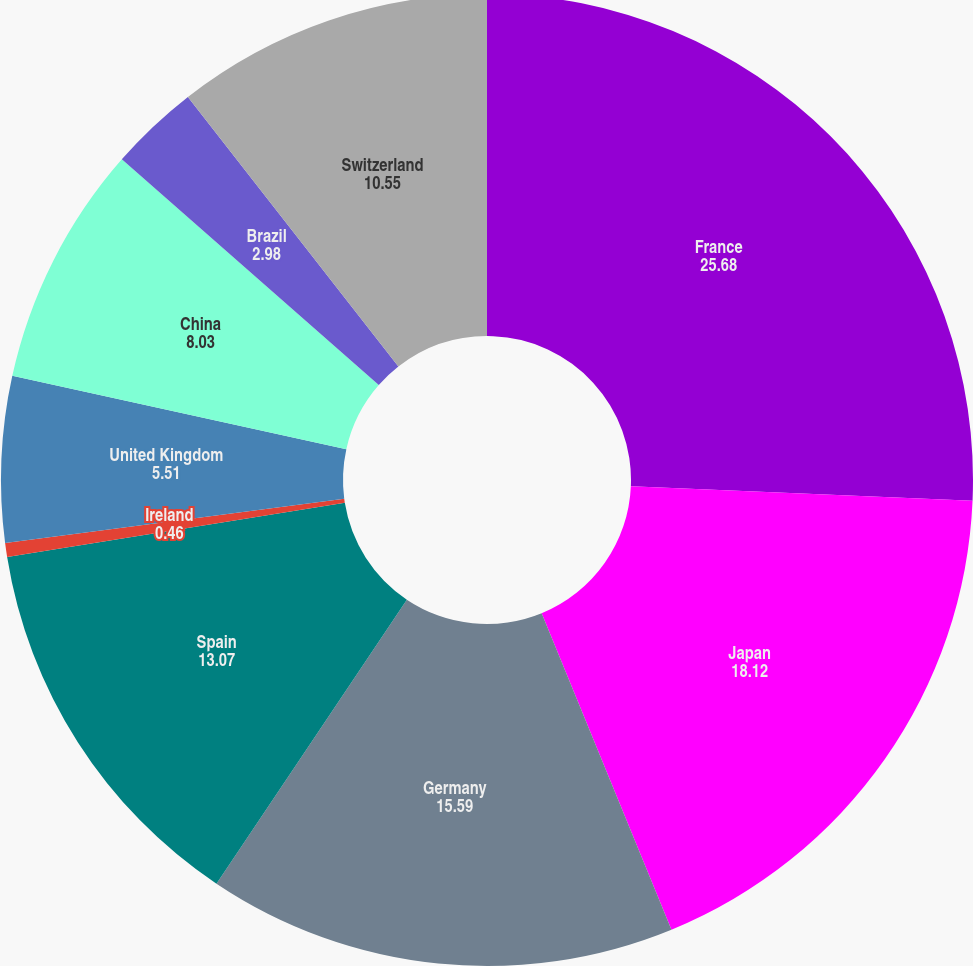Convert chart. <chart><loc_0><loc_0><loc_500><loc_500><pie_chart><fcel>France<fcel>Japan<fcel>Germany<fcel>Spain<fcel>Ireland<fcel>United Kingdom<fcel>China<fcel>Brazil<fcel>Switzerland<nl><fcel>25.68%<fcel>18.12%<fcel>15.59%<fcel>13.07%<fcel>0.46%<fcel>5.51%<fcel>8.03%<fcel>2.98%<fcel>10.55%<nl></chart> 